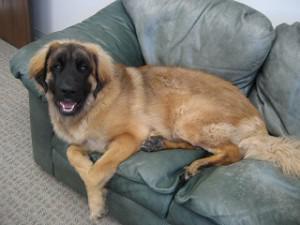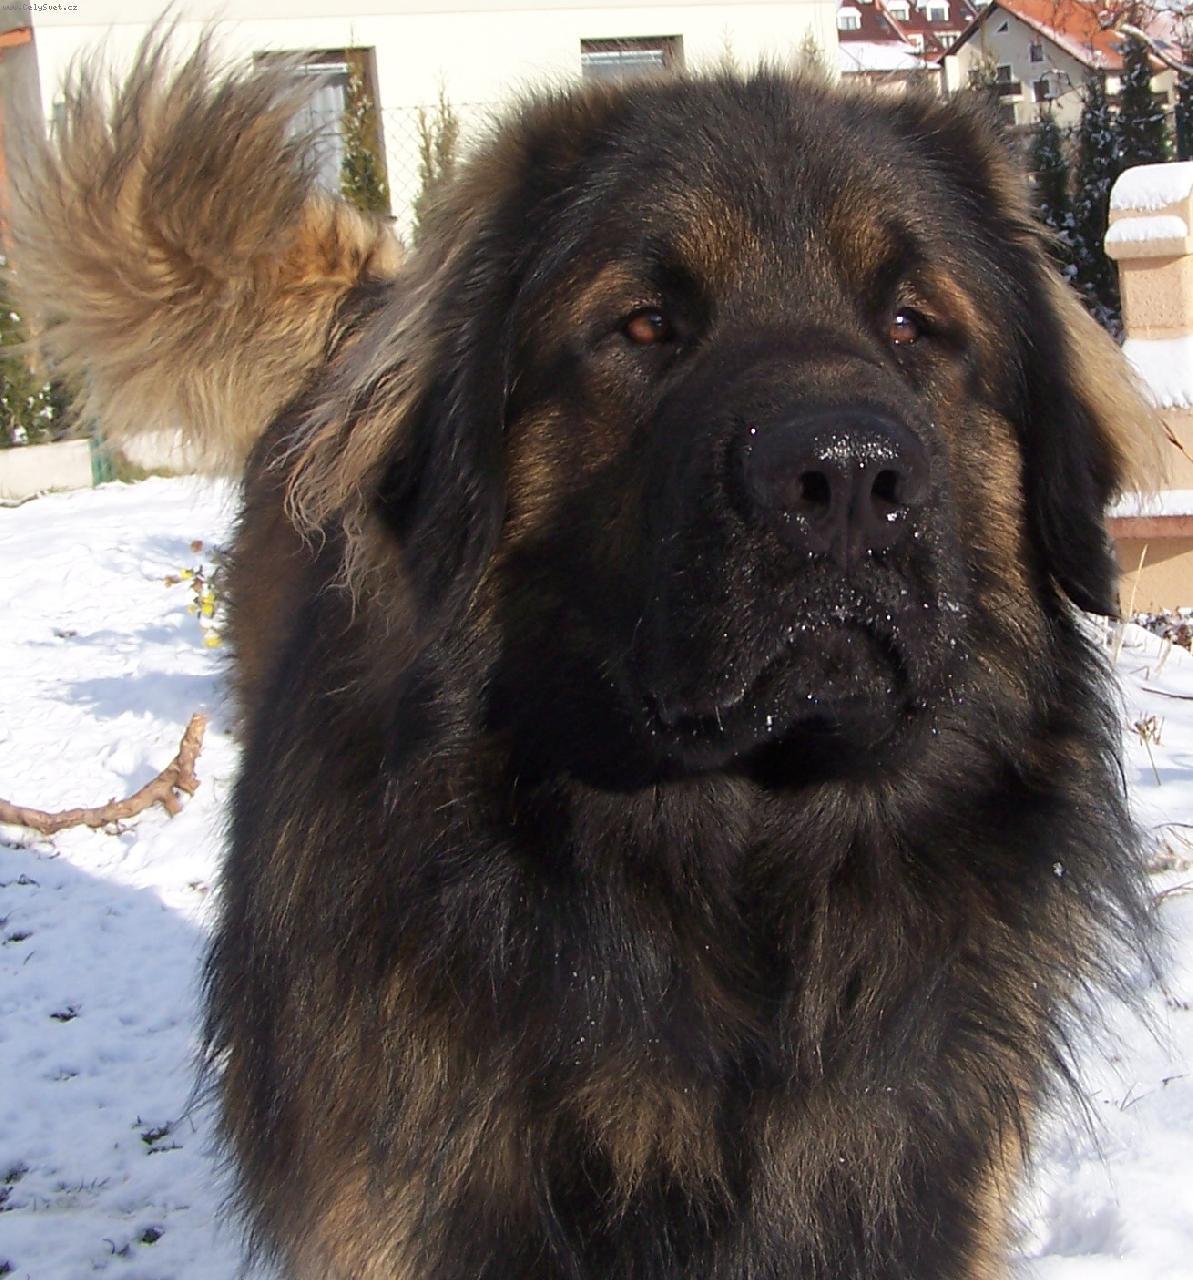The first image is the image on the left, the second image is the image on the right. Evaluate the accuracy of this statement regarding the images: "One image in the pair is an outdoor scene, while the other is clearly indoors.". Is it true? Answer yes or no. Yes. 